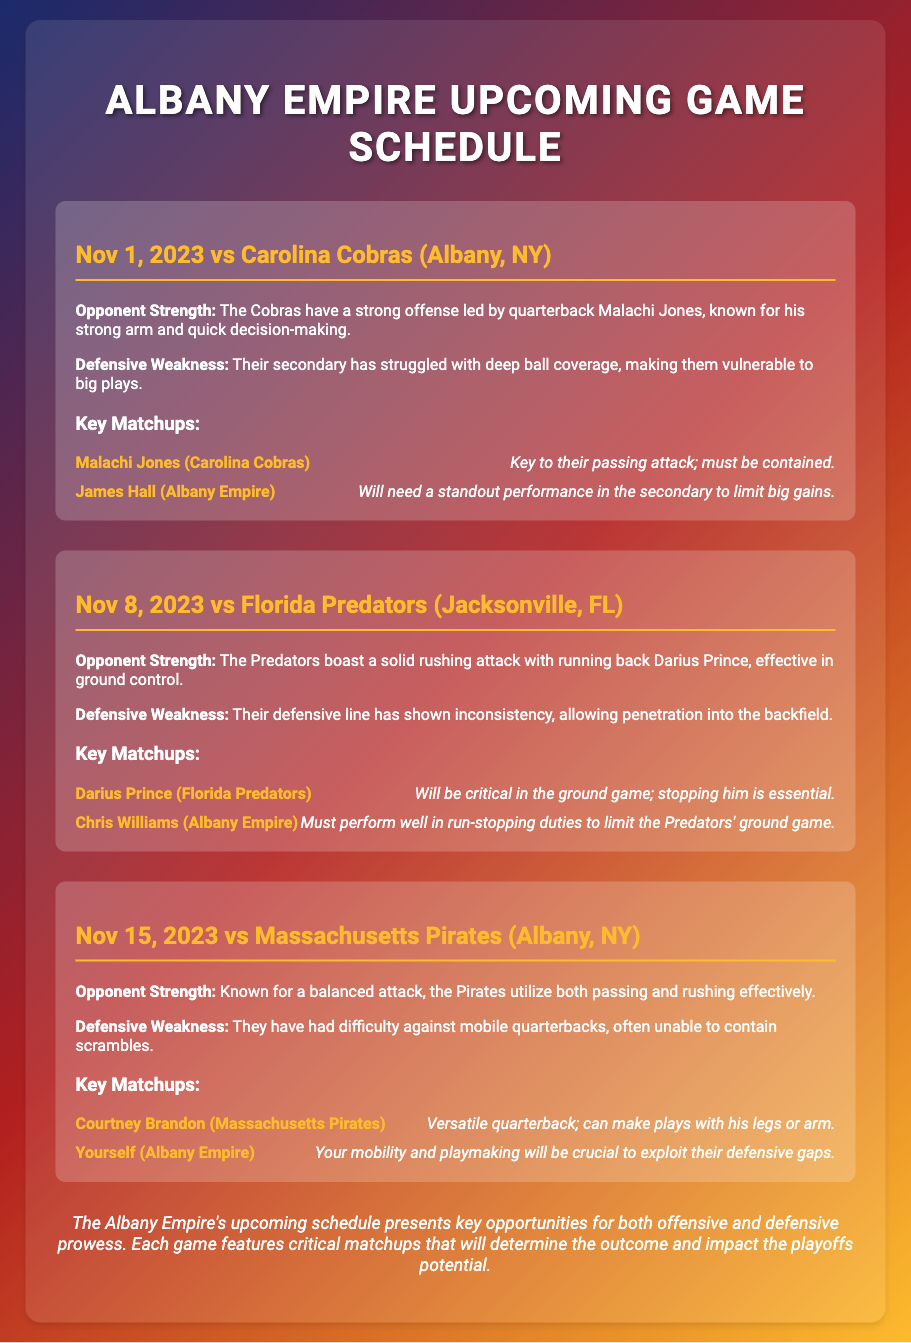what is the date of the first game? The first game listed in the document is scheduled for November 1, 2023.
Answer: November 1, 2023 who is the quarterback for the Carolina Cobras? The document identifies Malachi Jones as the quarterback for the Carolina Cobras.
Answer: Malachi Jones what is the defensive weakness of the Florida Predators? The document states that the Florida Predators' defensive line has shown inconsistency, allowing penetration into the backfield.
Answer: Inconsistency in the defensive line who needs to perform well in the run-stopping duties against the Predators? The document specifies Chris Williams as the player who must perform well in run-stopping duties against Florida Predators.
Answer: Chris Williams which team is known for a balanced attack? The Massachusetts Pirates are noted for their balanced attack in the document.
Answer: Massachusetts Pirates how does the document categorize the upcoming schedule for Albany Empire? The document categorizes the upcoming schedule as presenting key opportunities for offensive and defensive prowess.
Answer: Key opportunities who is the key to Carolina Cobras' passing attack? Malachi Jones is identified as key to the Carolina Cobras' passing attack.
Answer: Malachi Jones what is expected from yourself during the game against the Massachusetts Pirates? The document states that your mobility and playmaking will be crucial to exploit their defensive gaps.
Answer: Mobility and playmaking 